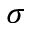<formula> <loc_0><loc_0><loc_500><loc_500>\sigma</formula> 